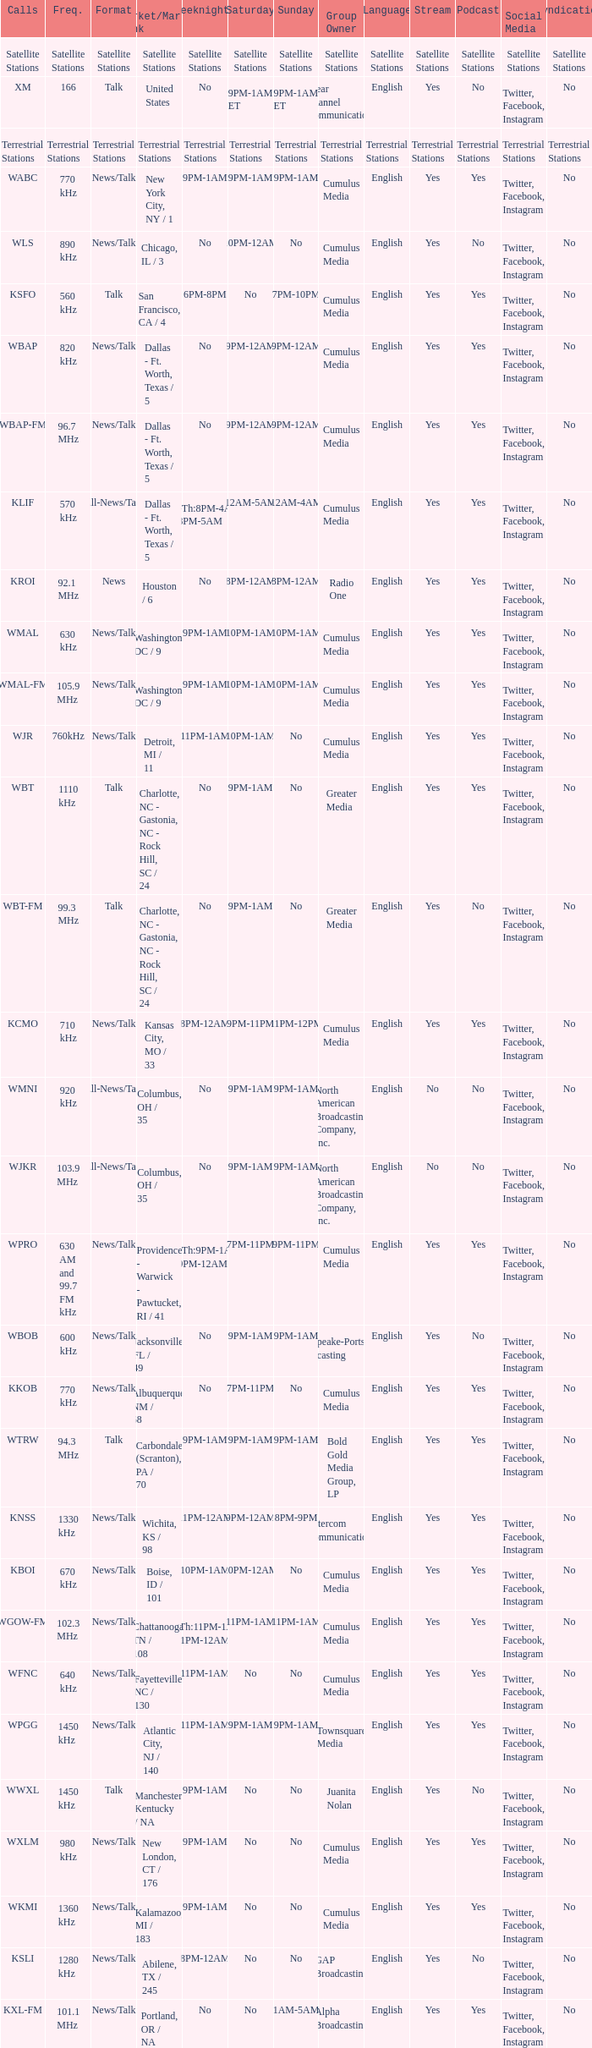What is the market for the 11pm-1am Saturday game? Chattanooga, TN / 108. 